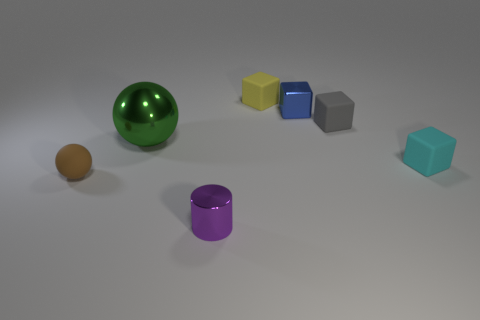What number of other objects are there of the same material as the small ball?
Make the answer very short. 3. What number of objects are rubber objects behind the gray matte cube or small blocks behind the large green sphere?
Offer a terse response. 3. Does the small matte thing to the right of the tiny gray cube have the same shape as the matte object on the left side of the big green ball?
Keep it short and to the point. No. What is the shape of the gray thing that is the same size as the purple metallic object?
Keep it short and to the point. Cube. How many shiny things are either yellow things or tiny brown things?
Provide a succinct answer. 0. Is the material of the small object on the left side of the purple metallic cylinder the same as the small object in front of the tiny brown rubber thing?
Ensure brevity in your answer.  No. What color is the small sphere that is made of the same material as the gray cube?
Keep it short and to the point. Brown. Are there more gray blocks that are behind the purple cylinder than green things that are to the right of the tiny blue thing?
Offer a terse response. Yes. Are there any tiny gray rubber cubes?
Offer a very short reply. Yes. What number of objects are green objects or gray objects?
Make the answer very short. 2. 